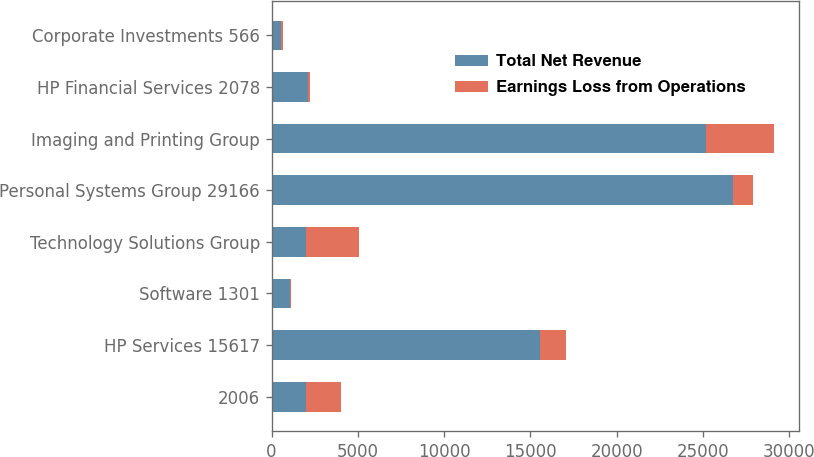<chart> <loc_0><loc_0><loc_500><loc_500><stacked_bar_chart><ecel><fcel>2006<fcel>HP Services 15617<fcel>Software 1301<fcel>Technology Solutions Group<fcel>Personal Systems Group 29166<fcel>Imaging and Printing Group<fcel>HP Financial Services 2078<fcel>Corporate Investments 566<nl><fcel>Total Net Revenue<fcel>2005<fcel>15536<fcel>1061<fcel>2005<fcel>26741<fcel>25155<fcel>2102<fcel>523<nl><fcel>Earnings Loss from Operations<fcel>2006<fcel>1507<fcel>85<fcel>3038<fcel>1152<fcel>3978<fcel>147<fcel>151<nl></chart> 